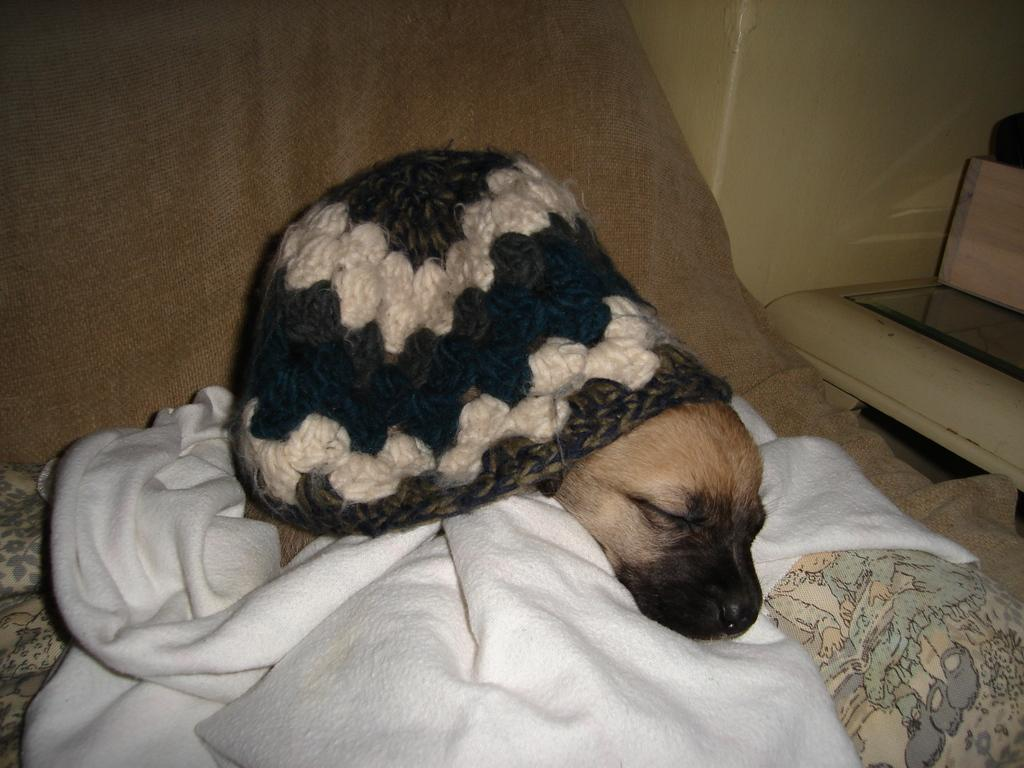What type of animal is in the image? There is a dog in the image. What type of clothing accessory is in the image? There is a cap in the image. What type of material is in the image? There is cloth in the image. What type of furniture is in the image? There is a bed in the image. What can be seen in the background of the image? There is a wall and objects visible in the background of the image. Can you see the dog's elbow in the image? There is no mention of an elbow in the image, as it features a dog, cap, cloth, bed, wall, and objects in the background. 